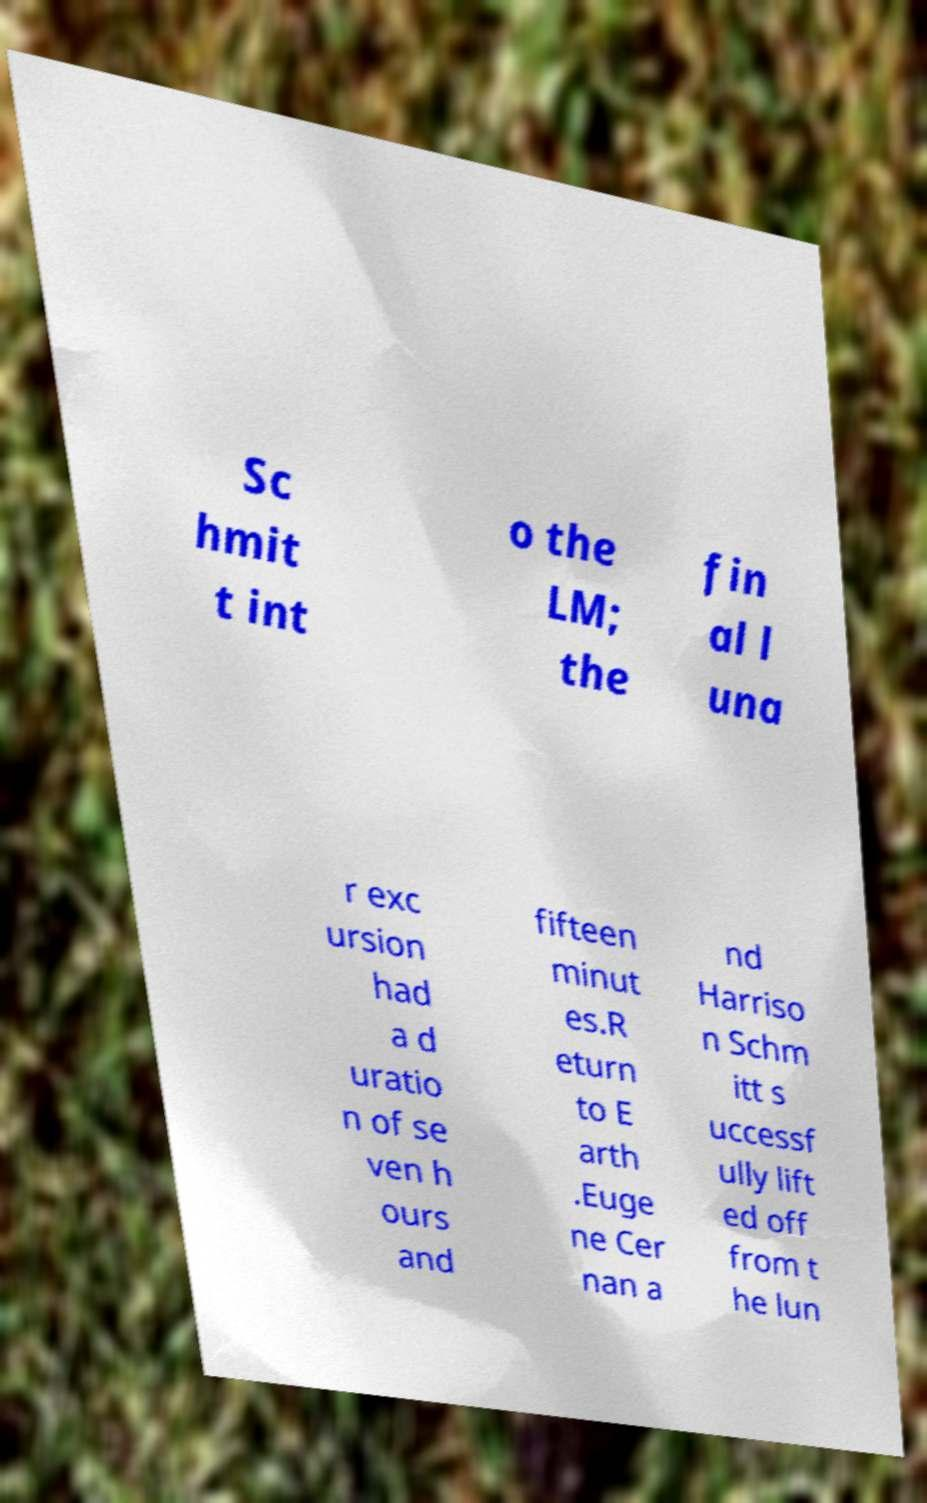Please identify and transcribe the text found in this image. Sc hmit t int o the LM; the fin al l una r exc ursion had a d uratio n of se ven h ours and fifteen minut es.R eturn to E arth .Euge ne Cer nan a nd Harriso n Schm itt s uccessf ully lift ed off from t he lun 